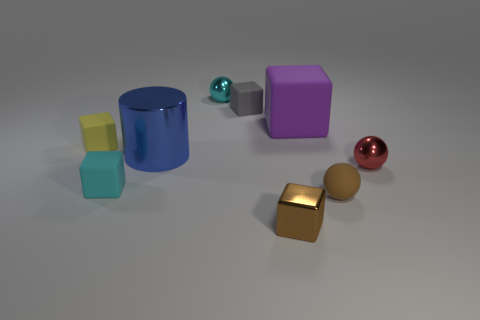There is a metallic sphere behind the tiny yellow thing; what color is it?
Ensure brevity in your answer.  Cyan. There is a yellow matte thing that is the same size as the brown shiny object; what shape is it?
Your answer should be very brief. Cube. There is a purple rubber block; how many blocks are behind it?
Your answer should be very brief. 1. How many objects are big purple matte things or small purple matte blocks?
Provide a succinct answer. 1. There is a tiny object that is in front of the small yellow block and on the left side of the small brown metal block; what shape is it?
Ensure brevity in your answer.  Cube. How many large purple matte things are there?
Give a very brief answer. 1. There is a large object that is made of the same material as the tiny red sphere; what is its color?
Your response must be concise. Blue. Is the number of tiny cyan rubber cubes greater than the number of metallic spheres?
Your answer should be very brief. No. There is a rubber object that is in front of the metallic cylinder and on the left side of the large matte block; what size is it?
Ensure brevity in your answer.  Small. What material is the small cube that is the same color as the tiny matte sphere?
Keep it short and to the point. Metal. 